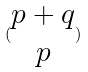<formula> <loc_0><loc_0><loc_500><loc_500>( \begin{matrix} p + q \\ p \end{matrix} )</formula> 